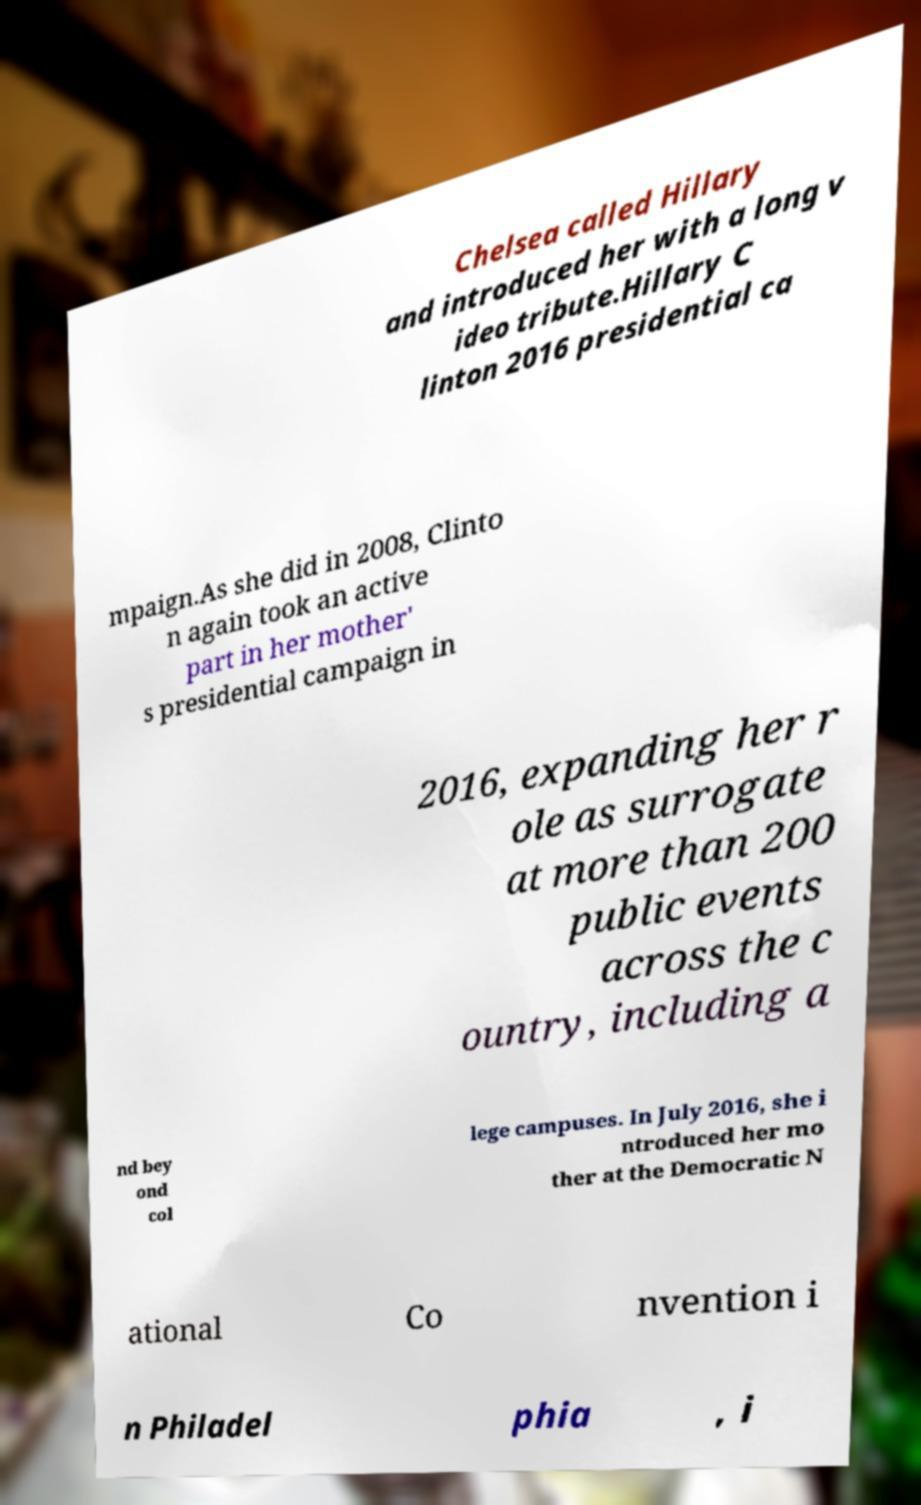Can you accurately transcribe the text from the provided image for me? Chelsea called Hillary and introduced her with a long v ideo tribute.Hillary C linton 2016 presidential ca mpaign.As she did in 2008, Clinto n again took an active part in her mother' s presidential campaign in 2016, expanding her r ole as surrogate at more than 200 public events across the c ountry, including a nd bey ond col lege campuses. In July 2016, she i ntroduced her mo ther at the Democratic N ational Co nvention i n Philadel phia , i 